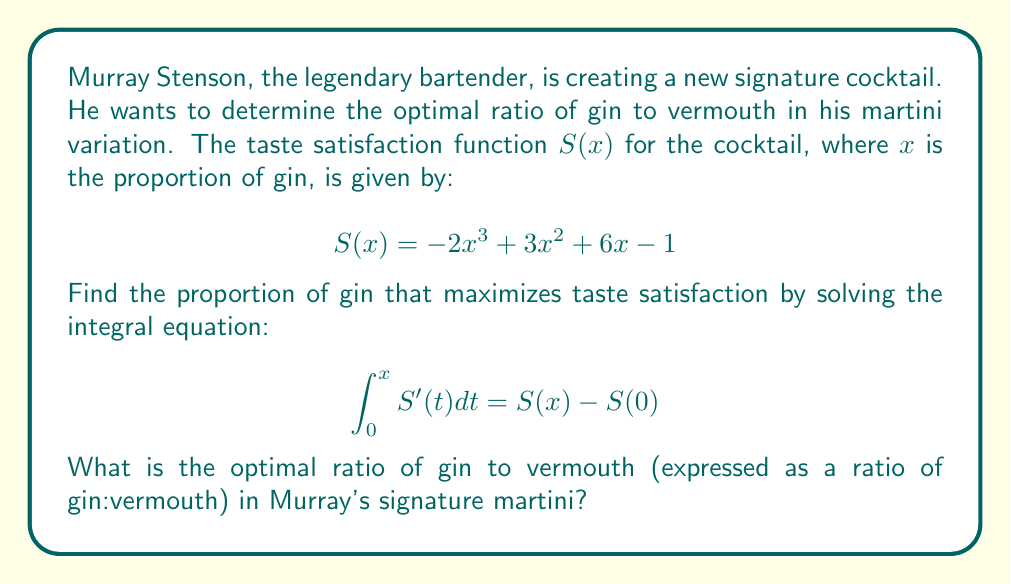Provide a solution to this math problem. To solve this problem, we'll follow these steps:

1) First, we need to find $S'(x)$ by differentiating $S(x)$:
   $$S'(x) = -6x^2 + 6x + 6$$

2) Now, we set up the integral equation:
   $$\int_0^x (-6t^2 + 6t + 6) dt = S(x) - S(0)$$

3) Let's solve the left side of the equation:
   $$\left[-2t^3 + 3t^2 + 6t\right]_0^x = -2x^3 + 3x^2 + 6x - 0$$

4) The right side of the equation is:
   $$S(x) - S(0) = (-2x^3 + 3x^2 + 6x - 1) - (-1) = -2x^3 + 3x^2 + 6x$$

5) We can see that both sides of the equation are identical, confirming that our original function $S(x)$ satisfies the integral equation.

6) To find the maximum of $S(x)$, we need to find where $S'(x) = 0$:
   $$-6x^2 + 6x + 6 = 0$$

7) This is a quadratic equation. We can solve it using the quadratic formula:
   $$x = \frac{-b \pm \sqrt{b^2 - 4ac}}{2a}$$
   where $a=-6$, $b=6$, and $c=6$

8) Solving this:
   $$x = \frac{-6 \pm \sqrt{36 - 4(-6)(6)}}{2(-6)} = \frac{-6 \pm \sqrt{180}}{-12} = \frac{-6 \pm 6\sqrt{5}}{-12}$$

9) This gives us two solutions:
   $$x_1 = \frac{1 + \sqrt{5}}{2} \approx 1.618 \quad \text{and} \quad x_2 = \frac{1 - \sqrt{5}}{2} \approx -0.618$$

10) Since $x$ represents a proportion, we can discard the negative solution. The maximum occurs at $x = \frac{1 + \sqrt{5}}{2}$.

11) This means the optimal ratio of gin to vermouth is $\frac{1 + \sqrt{5}}{2} : (1 - \frac{1 + \sqrt{5}}{2}) = \frac{1 + \sqrt{5}}{2} : \frac{3 - \sqrt{5}}{2}$.
Answer: $(\frac{1 + \sqrt{5}}{2}) : (\frac{3 - \sqrt{5}}{2})$ or approximately 1.618:0.382 